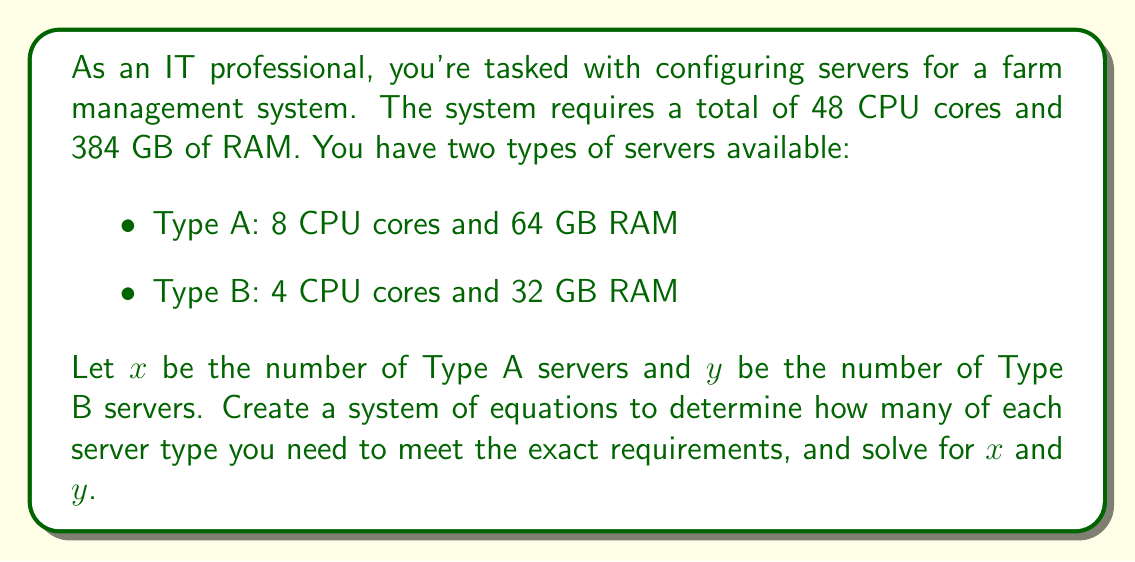Could you help me with this problem? To solve this problem, we need to set up a system of equations based on the given information:

1. Set up the equations:
   For CPU cores: $8x + 4y = 48$
   For RAM: $64x + 32y = 384$

2. Simplify the RAM equation:
   $64x + 32y = 384$
   Divide both sides by 32:
   $2x + y = 12$

3. Now we have a simplified system of equations:
   $8x + 4y = 48$
   $2x + y = 12$

4. Solve for $y$ in the second equation:
   $y = 12 - 2x$

5. Substitute this expression for $y$ in the first equation:
   $8x + 4(12 - 2x) = 48$

6. Simplify:
   $8x + 48 - 8x = 48$
   $48 = 48$

7. This identity shows that the equations are consistent, but we need another step to find unique values for $x$ and $y$.

8. Since $y = 12 - 2x$, and we need non-negative integer solutions, we can deduce:
   $x = 4$ and $y = 4$

9. Verify the solution:
   For CPU cores: $8(4) + 4(4) = 32 + 16 = 48$
   For RAM: $64(4) + 32(4) = 256 + 128 = 384$

Therefore, we need 4 Type A servers and 4 Type B servers to meet the exact requirements.
Answer: 4 Type A servers, 4 Type B servers 